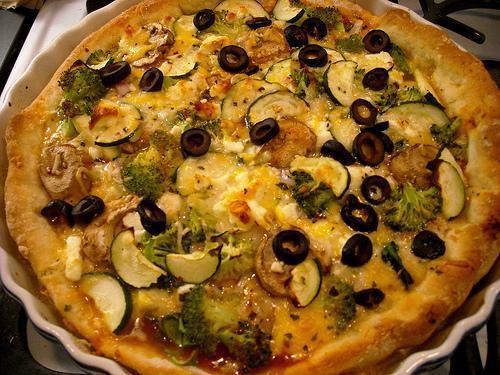How many pizzas are there?
Give a very brief answer. 1. 